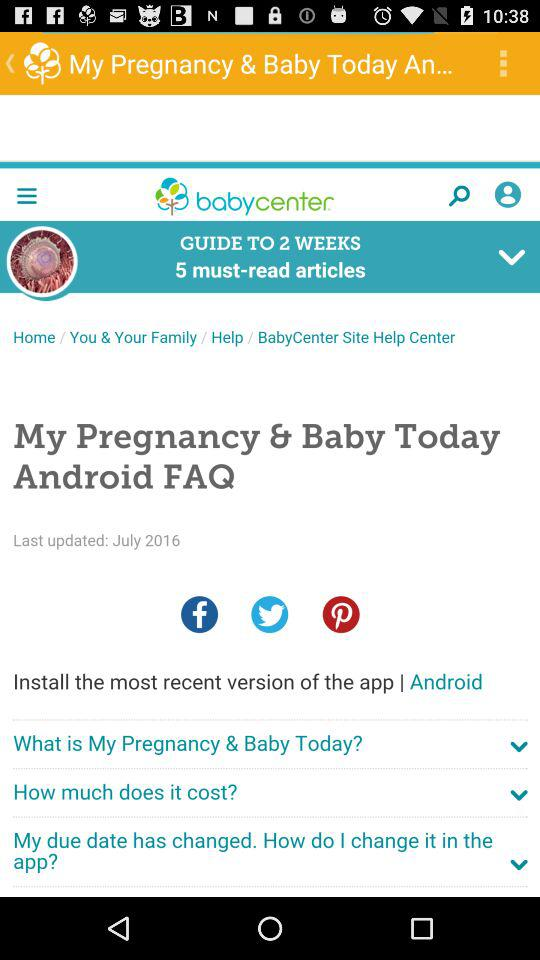What is the date when the articles were updated? The article was updated on July 2016. 